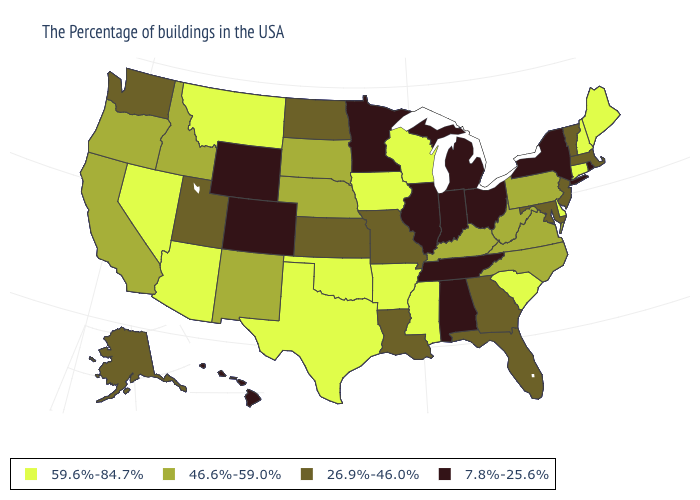Among the states that border Nevada , which have the highest value?
Be succinct. Arizona. Among the states that border Washington , which have the highest value?
Write a very short answer. Idaho, Oregon. Which states have the lowest value in the MidWest?
Keep it brief. Ohio, Michigan, Indiana, Illinois, Minnesota. Among the states that border Florida , which have the lowest value?
Answer briefly. Alabama. Which states have the lowest value in the West?
Write a very short answer. Wyoming, Colorado, Hawaii. Name the states that have a value in the range 7.8%-25.6%?
Concise answer only. Rhode Island, New York, Ohio, Michigan, Indiana, Alabama, Tennessee, Illinois, Minnesota, Wyoming, Colorado, Hawaii. Does the first symbol in the legend represent the smallest category?
Keep it brief. No. What is the value of Alaska?
Give a very brief answer. 26.9%-46.0%. Name the states that have a value in the range 26.9%-46.0%?
Keep it brief. Massachusetts, Vermont, New Jersey, Maryland, Florida, Georgia, Louisiana, Missouri, Kansas, North Dakota, Utah, Washington, Alaska. What is the value of New Hampshire?
Answer briefly. 59.6%-84.7%. What is the value of New Jersey?
Write a very short answer. 26.9%-46.0%. Does Colorado have the lowest value in the West?
Short answer required. Yes. What is the value of Delaware?
Keep it brief. 59.6%-84.7%. Does Ohio have the highest value in the MidWest?
Write a very short answer. No. 